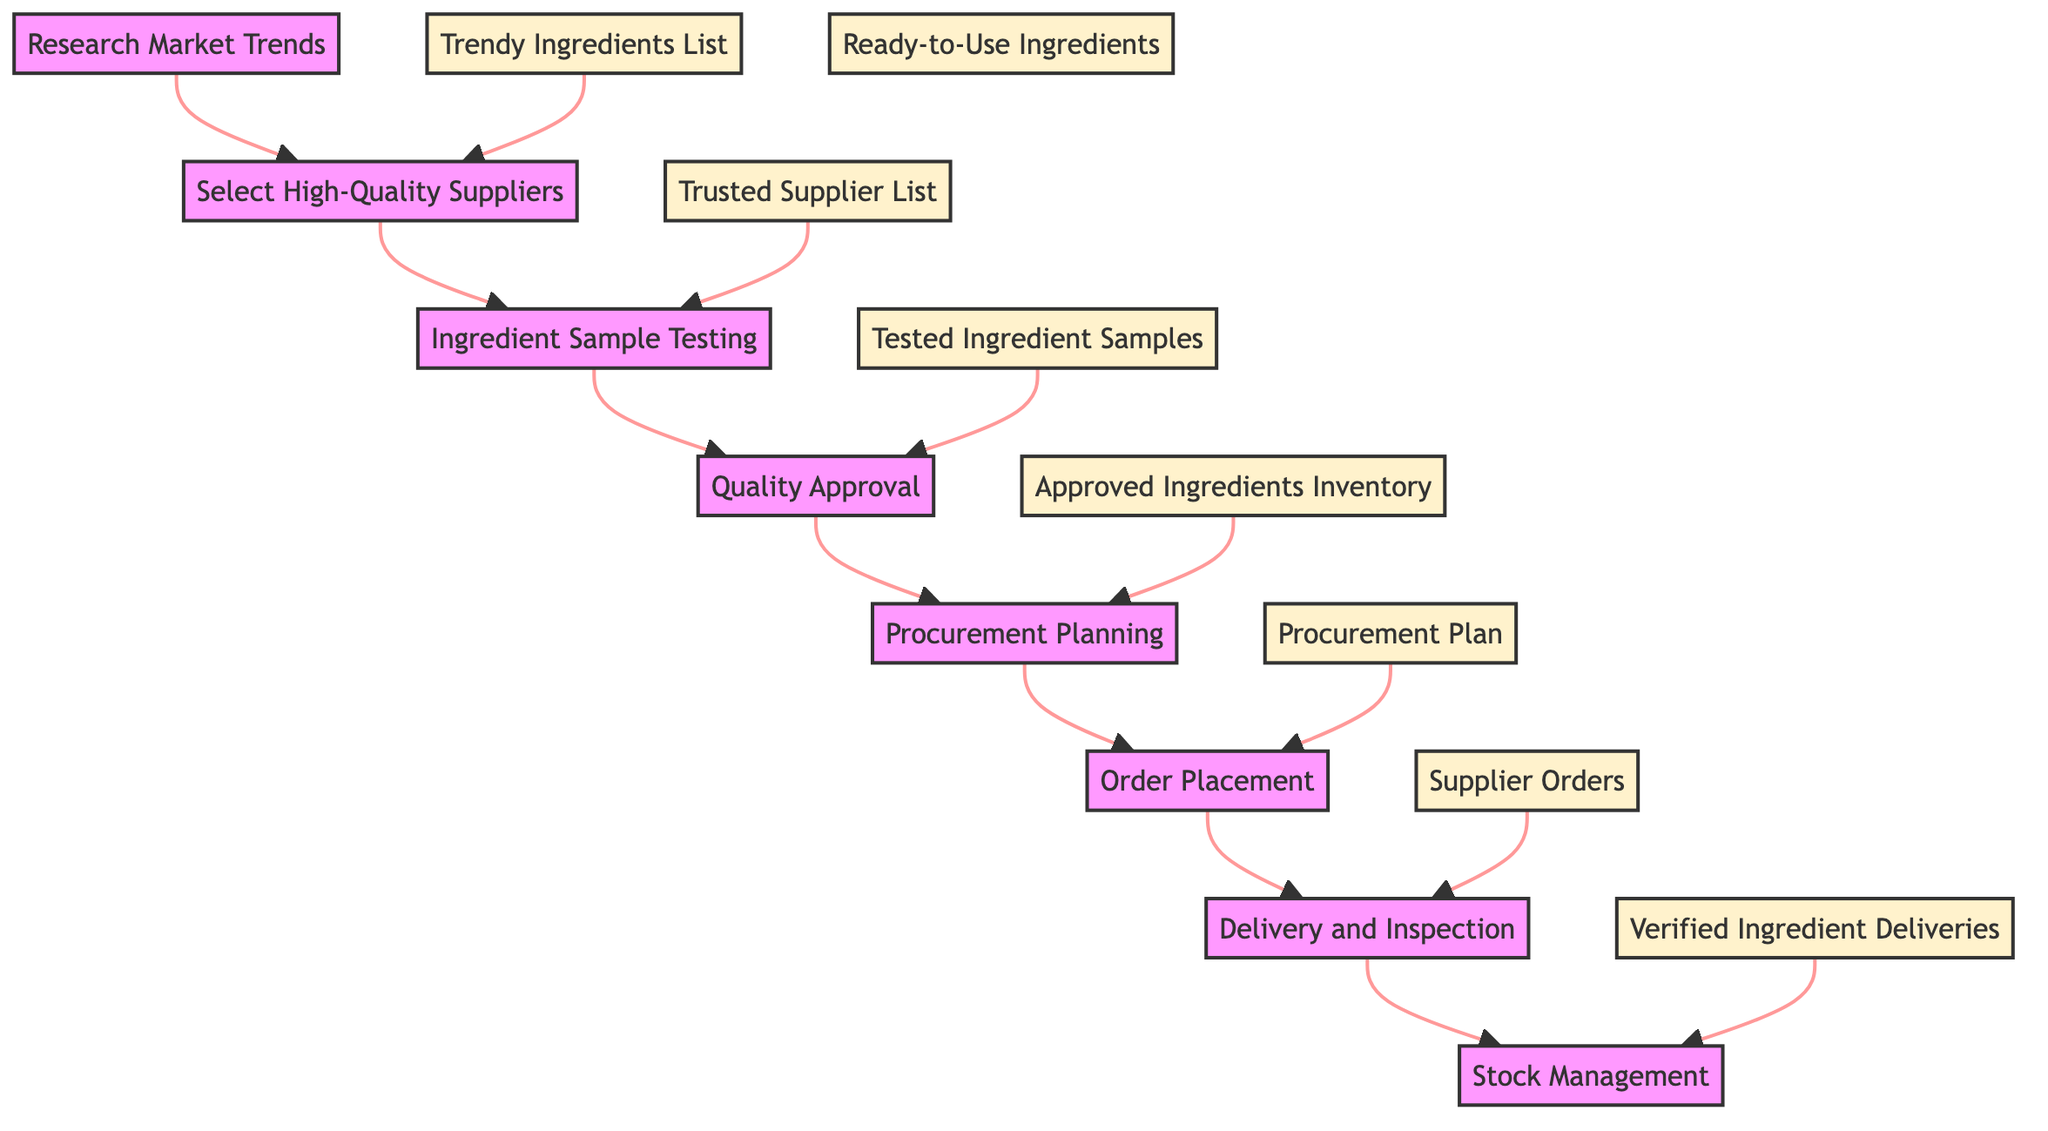What is the final output of the process? The flowchart ends with the "Ready-to-Use Ingredients" node, which means that after all preceding steps, the final output achieved is the readiness of ingredients for use.
Answer: Ready-to-Use Ingredients How many total nodes are in the diagram? By counting each unique step in the flowchart, including both inputs and outputs, we identify eight nodes: Research Market Trends, Select High-Quality Suppliers, Ingredient Sample Testing, Quality Approval, Procurement Planning, Order Placement, Delivery and Inspection, Stock Management.
Answer: Eight What is the input for the "Delivery and Inspection" node? According to the flowchart, the "Delivery and Inspection" step receives input from the "Supplier Orders" node, which links to it directly, indicating that orders placed are received for inspection.
Answer: Supplier Orders Which node is directly connected after "Quality Approval"? The diagram shows that the next step following "Quality Approval" is "Procurement Planning," indicating that once ingredients are approved, the planning for procurement begins.
Answer: Procurement Planning What does "Ingredient Sample Testing" output? In the flow, "Ingredient Sample Testing" leads to the output of "Tested Ingredient Samples," which represents the result after testing the samples from suppliers.
Answer: Tested Ingredient Samples What two nodes have the same output description as a preceding node's input? The "Stock Management" node and the "Delivery and Inspection" node both receive outputs that become inputs for processes in their respective following steps— "Verified Ingredient Deliveries" is the input for "Stock Management" and an output of "Delivery and Inspection."
Answer: Verified Ingredient Deliveries Identify the node that begins the process. The flowchart clearly starts with the "Research Market Trends" node, which initiates the entire ingredient sourcing and quality control process for the food stylist.
Answer: Research Market Trends How do "Order Placement" and "Delivery and Inspection" connect in the process? The diagram demonstrates a direct flow: "Order Placement" feeds into "Delivery and Inspection," meaning that once orders are placed, the next step is inspecting the delivered goods.
Answer: Delivery and Inspection What is the aim of "Procurement Planning" in this flow? The objective of the "Procurement Planning" node is clearly stated as planning the procurement of approved ingredients based on estimates, aligning the procurement with expected usage.
Answer: Procurement Plan 